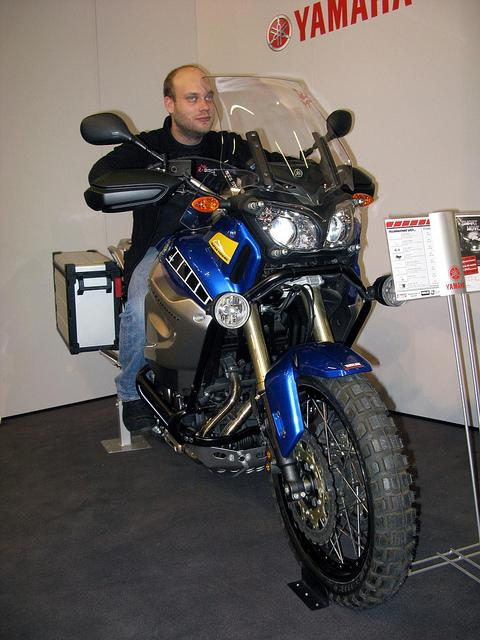What brand is the motorcycle?

Choices:
A) yamaha
B) harley
C) honda
D) suzuki yamaha 